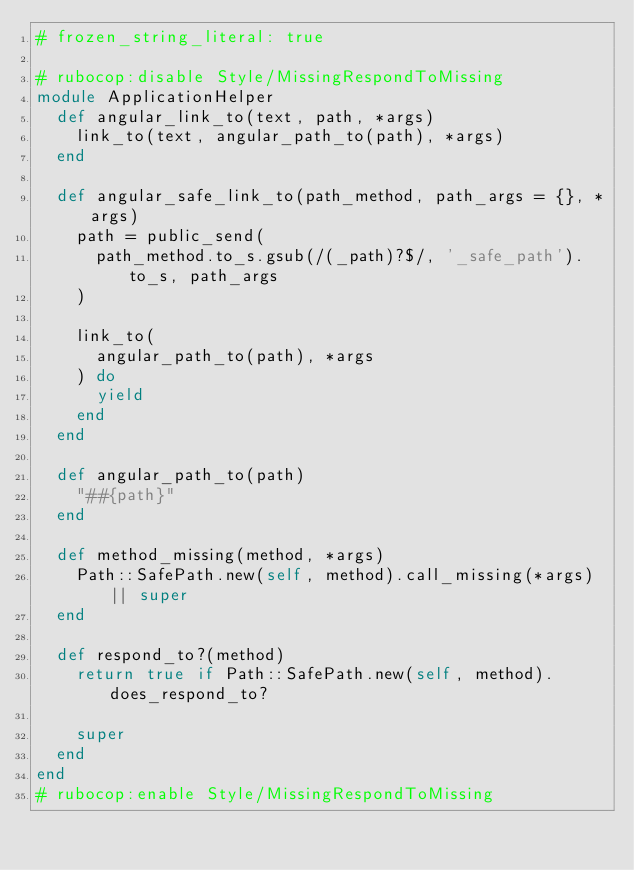<code> <loc_0><loc_0><loc_500><loc_500><_Ruby_># frozen_string_literal: true

# rubocop:disable Style/MissingRespondToMissing
module ApplicationHelper
  def angular_link_to(text, path, *args)
    link_to(text, angular_path_to(path), *args)
  end

  def angular_safe_link_to(path_method, path_args = {}, *args)
    path = public_send(
      path_method.to_s.gsub(/(_path)?$/, '_safe_path').to_s, path_args
    )

    link_to(
      angular_path_to(path), *args
    ) do
      yield
    end
  end

  def angular_path_to(path)
    "##{path}"
  end

  def method_missing(method, *args)
    Path::SafePath.new(self, method).call_missing(*args) || super
  end

  def respond_to?(method)
    return true if Path::SafePath.new(self, method).does_respond_to?

    super
  end
end
# rubocop:enable Style/MissingRespondToMissing
</code> 